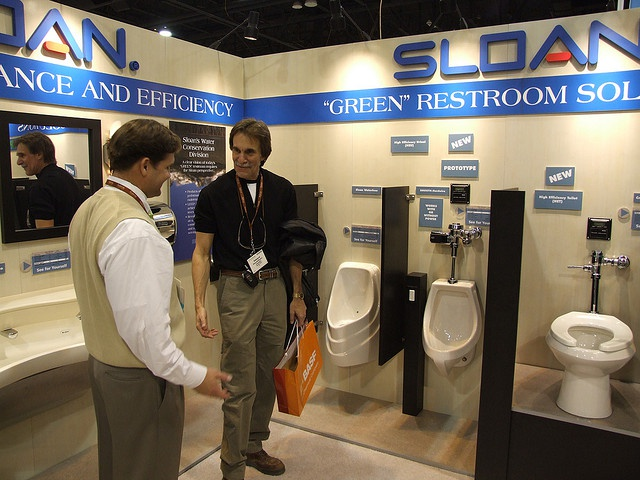Describe the objects in this image and their specific colors. I can see people in navy, black, tan, and olive tones, people in navy, black, gray, and olive tones, toilet in navy, gray, tan, and beige tones, toilet in navy, tan, and gray tones, and toilet in navy, tan, and gray tones in this image. 